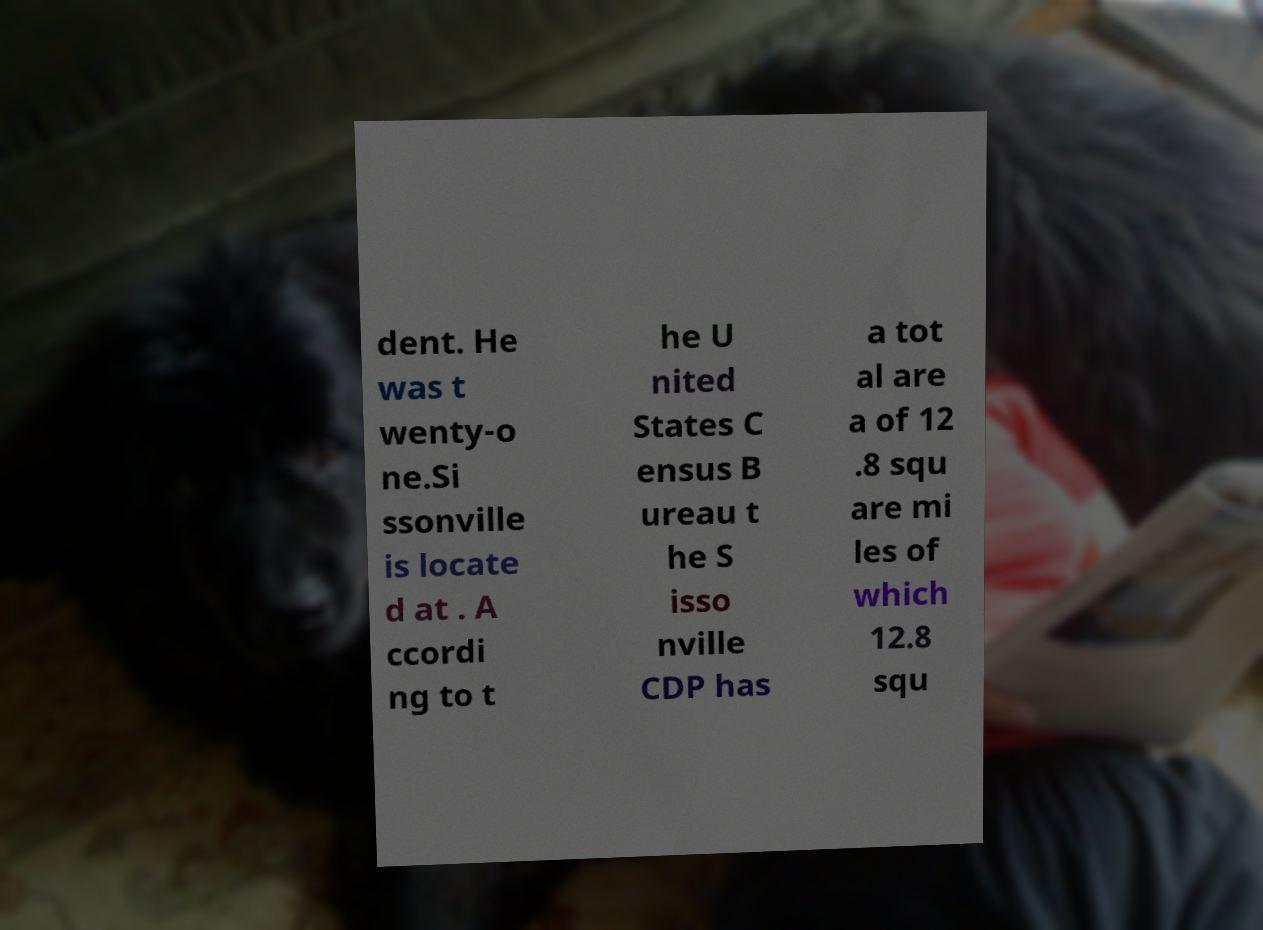Can you accurately transcribe the text from the provided image for me? dent. He was t wenty-o ne.Si ssonville is locate d at . A ccordi ng to t he U nited States C ensus B ureau t he S isso nville CDP has a tot al are a of 12 .8 squ are mi les of which 12.8 squ 